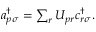Convert formula to latex. <formula><loc_0><loc_0><loc_500><loc_500>\begin{array} { r } { { a } _ { p \sigma } ^ { \dagger } = \sum _ { r } { U } _ { p r } { c } _ { r \sigma } ^ { \dagger } . } \end{array}</formula> 